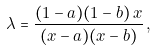<formula> <loc_0><loc_0><loc_500><loc_500>\lambda = \frac { ( 1 - a ) ( 1 - b ) \, x } { ( x - a ) ( x - b ) } \, ,</formula> 